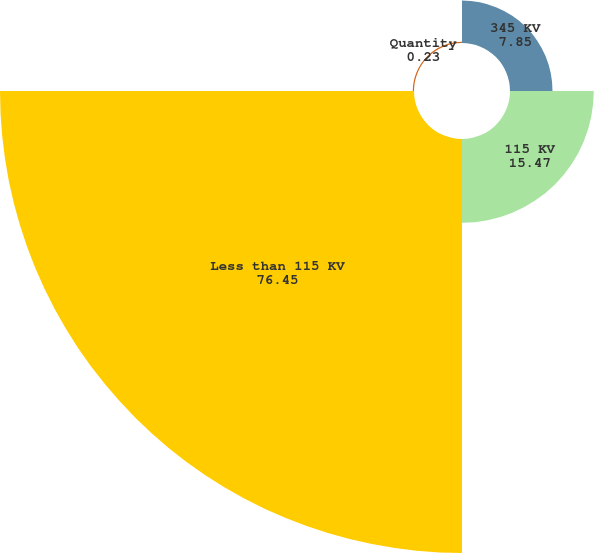<chart> <loc_0><loc_0><loc_500><loc_500><pie_chart><fcel>345 KV<fcel>115 KV<fcel>Less than 115 KV<fcel>Quantity<nl><fcel>7.85%<fcel>15.47%<fcel>76.45%<fcel>0.23%<nl></chart> 